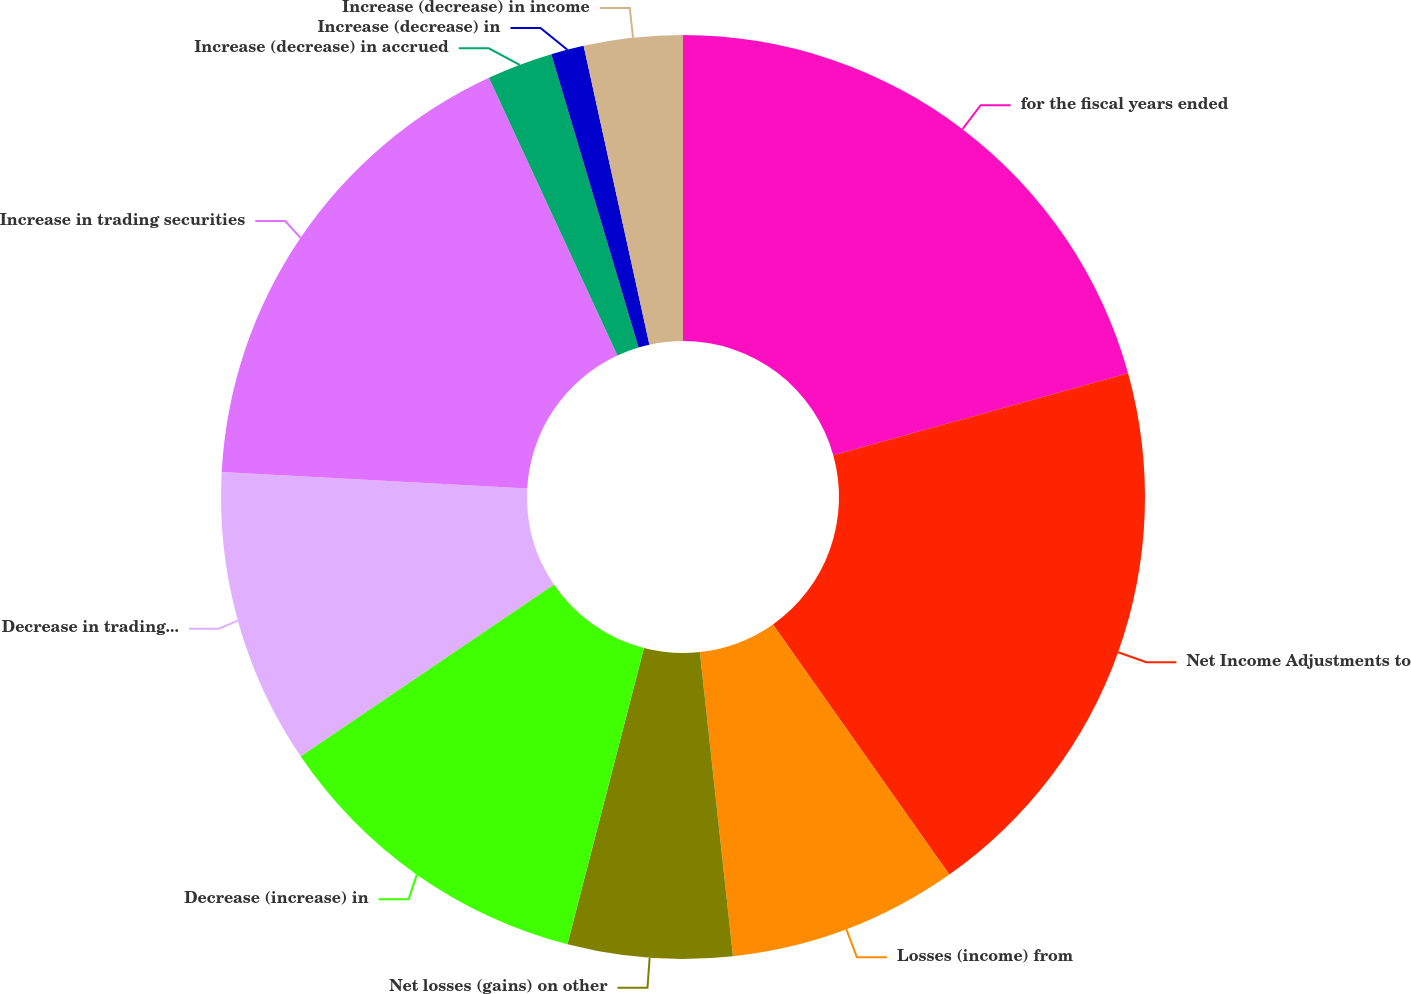Convert chart. <chart><loc_0><loc_0><loc_500><loc_500><pie_chart><fcel>for the fiscal years ended<fcel>Net Income Adjustments to<fcel>Losses (income) from<fcel>Net losses (gains) on other<fcel>Decrease (increase) in<fcel>Decrease in trading securities<fcel>Increase in trading securities<fcel>Increase (decrease) in accrued<fcel>Increase (decrease) in<fcel>Increase (decrease) in income<nl><fcel>20.68%<fcel>19.54%<fcel>8.05%<fcel>5.75%<fcel>11.49%<fcel>10.34%<fcel>17.24%<fcel>2.3%<fcel>1.15%<fcel>3.45%<nl></chart> 